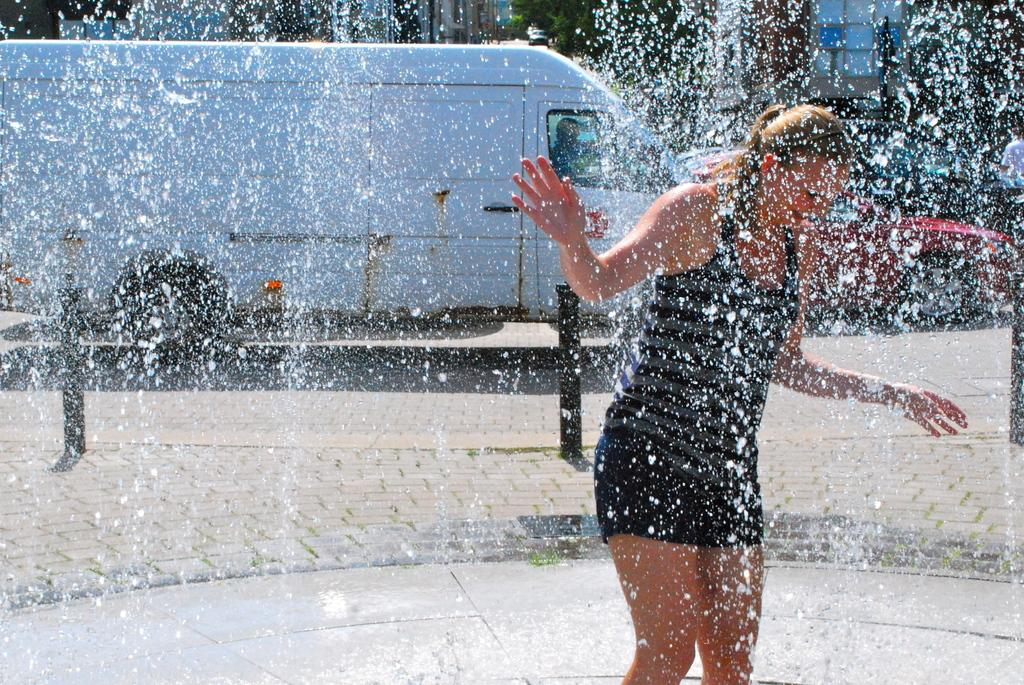Who is present in the image? There is a woman in the image. What is the woman doing in the image? The woman is playing in a fountain. What vehicles are visible in the image? There is a truck and a car visible in the image. What are the truck and car doing in the image? The truck and car are moving on a road. What type of waves can be seen crashing on the shore in the image? There are no waves or shore visible in the image; it features a woman playing in a fountain and vehicles moving on a road. 